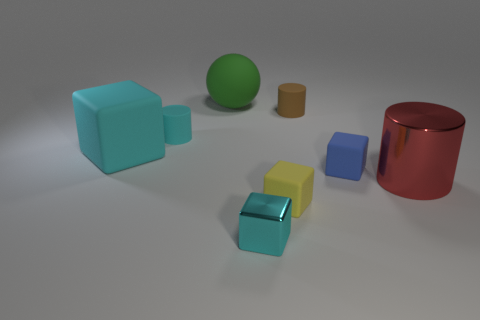There is a small cyan object that is the same shape as the red thing; what is it made of?
Make the answer very short. Rubber. What is the shape of the cyan object that is in front of the matte thing in front of the tiny blue object?
Keep it short and to the point. Cube. Does the tiny block behind the tiny yellow rubber block have the same material as the small cyan block?
Your answer should be very brief. No. Are there an equal number of cyan metal blocks behind the blue matte cube and things to the left of the green matte ball?
Ensure brevity in your answer.  No. What material is the cylinder that is the same color as the big matte block?
Give a very brief answer. Rubber. What number of red metallic cylinders are behind the small cyan thing behind the red cylinder?
Your answer should be very brief. 0. Does the small matte cube to the right of the small brown thing have the same color as the matte cube that is behind the small blue thing?
Your answer should be very brief. No. What material is the cube that is the same size as the green rubber sphere?
Give a very brief answer. Rubber. There is a tiny cyan object that is left of the tiny cube in front of the small matte cube that is in front of the blue rubber cube; what shape is it?
Your response must be concise. Cylinder. The cyan matte thing that is the same size as the red metal cylinder is what shape?
Offer a terse response. Cube. 